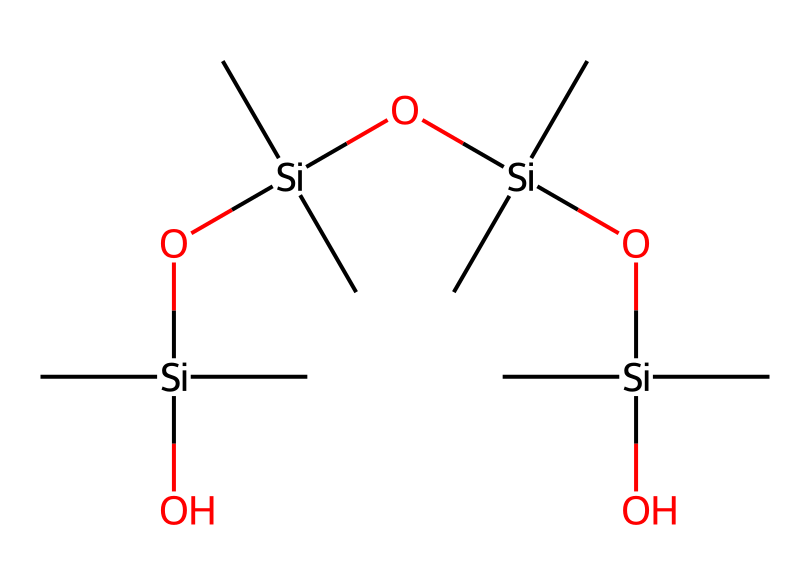What is the main element in this chemical's backbone? The backbone of the provided chemical structure primarily consists of silicon atoms, as observed in the repeated `Si` in the SMILES representation.
Answer: silicon How many oxygen atoms are present in this chemical? By examining the structure, there are four `O` atoms present, indicated by the instances of `O` in the SMILES representation.
Answer: four What is the molecular formula that corresponds to the structure? The molecular formula can be derived from counting the atoms: there are 12 carbon (C) atoms, 4 silicon (Si) atoms, and 4 oxygen (O) atoms, hence the formula is C12H36O4Si4.
Answer: C12H36O4Si4 How many siloxane linkages are present? The chemical structure shows three siloxane (Si-O) linkages connecting the different silicon units due to the `O[Si]` occurrences in the SMILES.
Answer: three What type of compound is represented by this structure? Analyzing the arrangement of silicon and oxygen, along with the presence of organic groups (methyl groups), indicates this is a siloxane polymer, a type of silicone compound.
Answer: siloxane polymer What functional groups are involved in this compound? The structure includes hydroxyl (–OH) groups and siloxane linkages (Si-O), which can be identified through the presence of `O` connected to `Si`.
Answer: hydroxyl and siloxane 